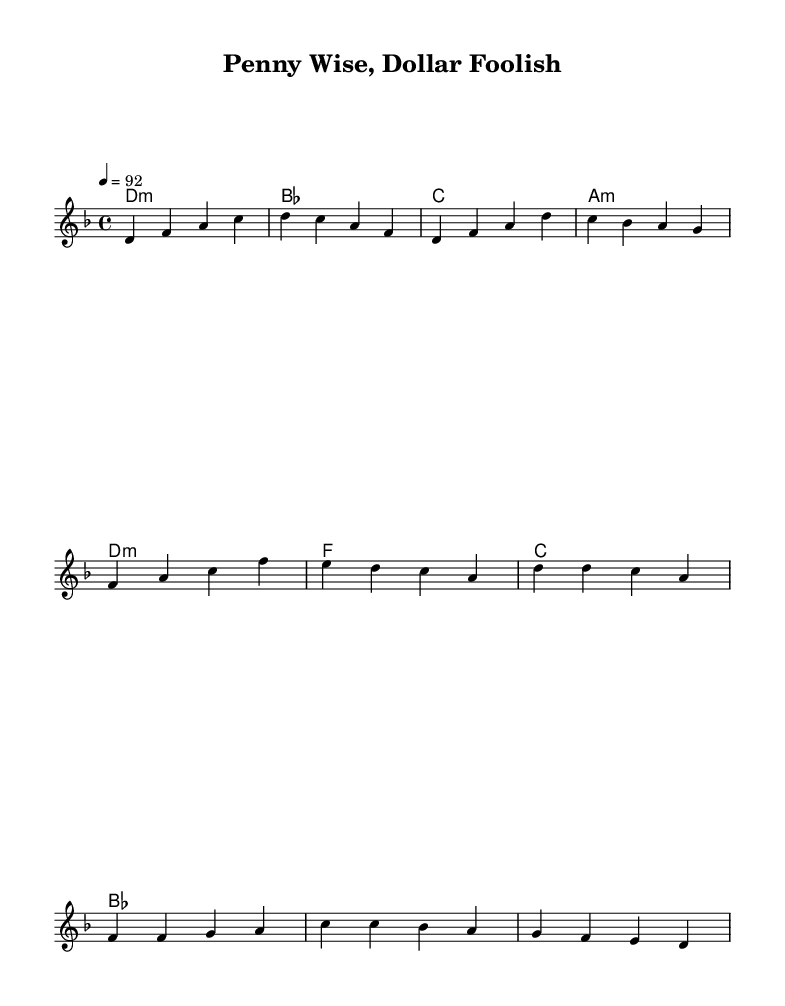What is the key signature of this music? The key signature is D minor, which has one flat (B flat).
Answer: D minor What is the time signature of this music? The time signature is four-four time, meaning there are four beats in each measure.
Answer: 4/4 What is the tempo marking of this music? The tempo marking indicates a speed of 92 beats per minute.
Answer: 92 How many measures are in the verse? The verse consists of four measures as indicated in the melody.
Answer: 4 What is the first chord played in the verse? The first chord indicated in the verse is D minor.
Answer: D minor What do the lyrics in the chorus suggest about spending habits? The lyrics suggest a conflict arising from being frugal versus being foolish with money in a relationship.
Answer: Conflict between frugality and foolish spending What is the overall theme explored in this rap song? The overall theme is the strain on love caused by differing spending habits between partners.
Answer: Relationship conflicts over spending habits 